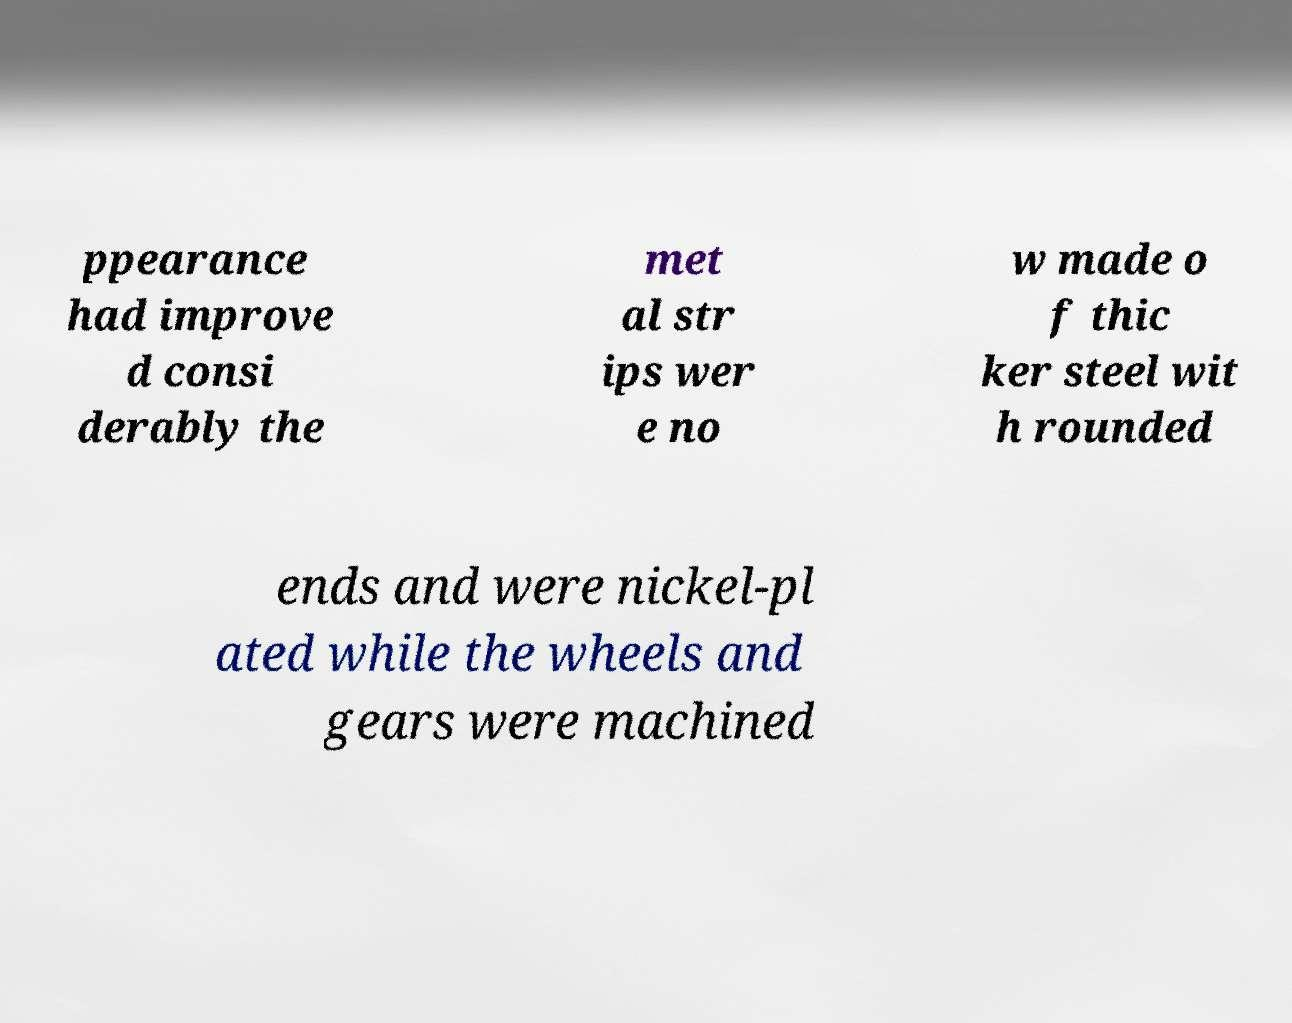Can you accurately transcribe the text from the provided image for me? ppearance had improve d consi derably the met al str ips wer e no w made o f thic ker steel wit h rounded ends and were nickel-pl ated while the wheels and gears were machined 